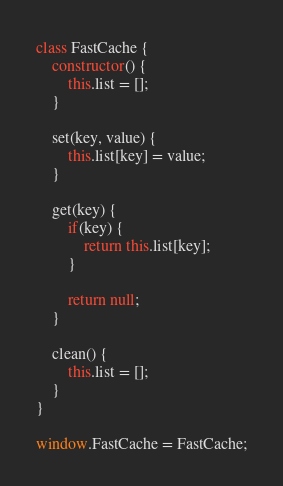<code> <loc_0><loc_0><loc_500><loc_500><_JavaScript_>class FastCache {
    constructor() {
        this.list = [];
    }

    set(key, value) {
        this.list[key] = value;
    }

    get(key) {
        if(key) {
            return this.list[key];
        }

        return null;
    }

    clean() {
        this.list = [];
    }
}

window.FastCache = FastCache;</code> 